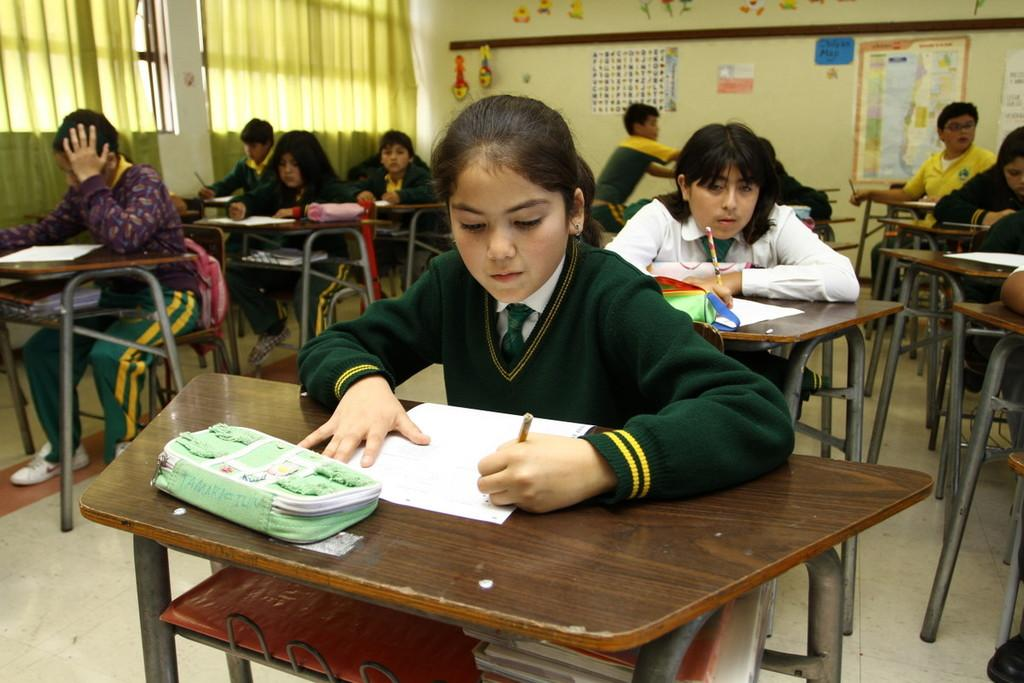Who is present in the image? There are children in the image. What are the children doing in the image? The children are sitting. What can be seen in front of the children? There are papers in front of the children. What can be seen in the background of the image? There are posts on the wall in the background of the image. What type of crayon is the scarecrow holding in the image? There is no scarecrow or crayon present in the image. What advice might the children's grandfather give them in the image? There is no grandfather present in the image, so it is not possible to determine what advice he might give. 